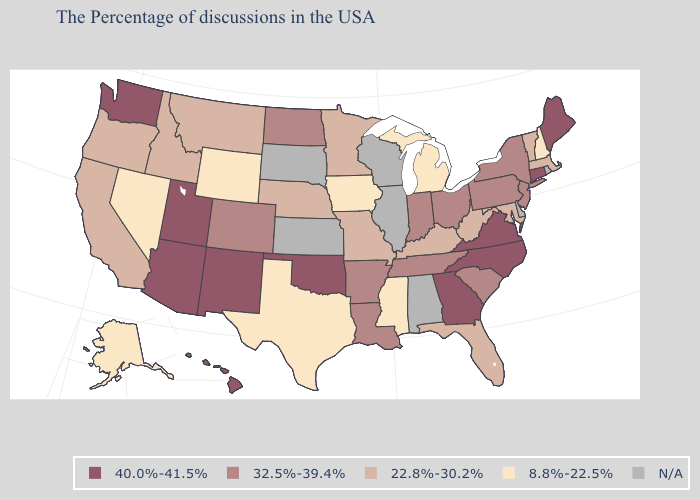How many symbols are there in the legend?
Be succinct. 5. Name the states that have a value in the range 22.8%-30.2%?
Quick response, please. Massachusetts, Vermont, Maryland, West Virginia, Florida, Kentucky, Missouri, Minnesota, Nebraska, Montana, Idaho, California, Oregon. Name the states that have a value in the range 8.8%-22.5%?
Be succinct. New Hampshire, Michigan, Mississippi, Iowa, Texas, Wyoming, Nevada, Alaska. What is the value of Kentucky?
Give a very brief answer. 22.8%-30.2%. Name the states that have a value in the range 32.5%-39.4%?
Short answer required. New York, New Jersey, Pennsylvania, South Carolina, Ohio, Indiana, Tennessee, Louisiana, Arkansas, North Dakota, Colorado. What is the value of Maine?
Quick response, please. 40.0%-41.5%. Name the states that have a value in the range 32.5%-39.4%?
Answer briefly. New York, New Jersey, Pennsylvania, South Carolina, Ohio, Indiana, Tennessee, Louisiana, Arkansas, North Dakota, Colorado. Name the states that have a value in the range 22.8%-30.2%?
Short answer required. Massachusetts, Vermont, Maryland, West Virginia, Florida, Kentucky, Missouri, Minnesota, Nebraska, Montana, Idaho, California, Oregon. What is the lowest value in states that border Indiana?
Write a very short answer. 8.8%-22.5%. What is the value of Florida?
Quick response, please. 22.8%-30.2%. Does Maine have the highest value in the Northeast?
Answer briefly. Yes. What is the value of Alabama?
Answer briefly. N/A. Does Ohio have the highest value in the MidWest?
Answer briefly. Yes. Among the states that border Oklahoma , which have the highest value?
Answer briefly. New Mexico. 